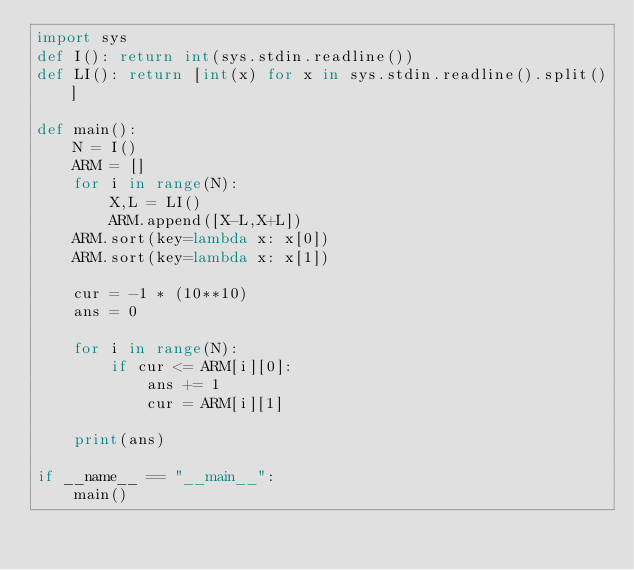<code> <loc_0><loc_0><loc_500><loc_500><_Python_>import sys
def I(): return int(sys.stdin.readline())
def LI(): return [int(x) for x in sys.stdin.readline().split()]

def main():
    N = I()
    ARM = []
    for i in range(N):
        X,L = LI()
        ARM.append([X-L,X+L])
    ARM.sort(key=lambda x: x[0])
    ARM.sort(key=lambda x: x[1])

    cur = -1 * (10**10)
    ans = 0

    for i in range(N):
        if cur <= ARM[i][0]:
            ans += 1
            cur = ARM[i][1]

    print(ans)

if __name__ == "__main__":
    main()
</code> 